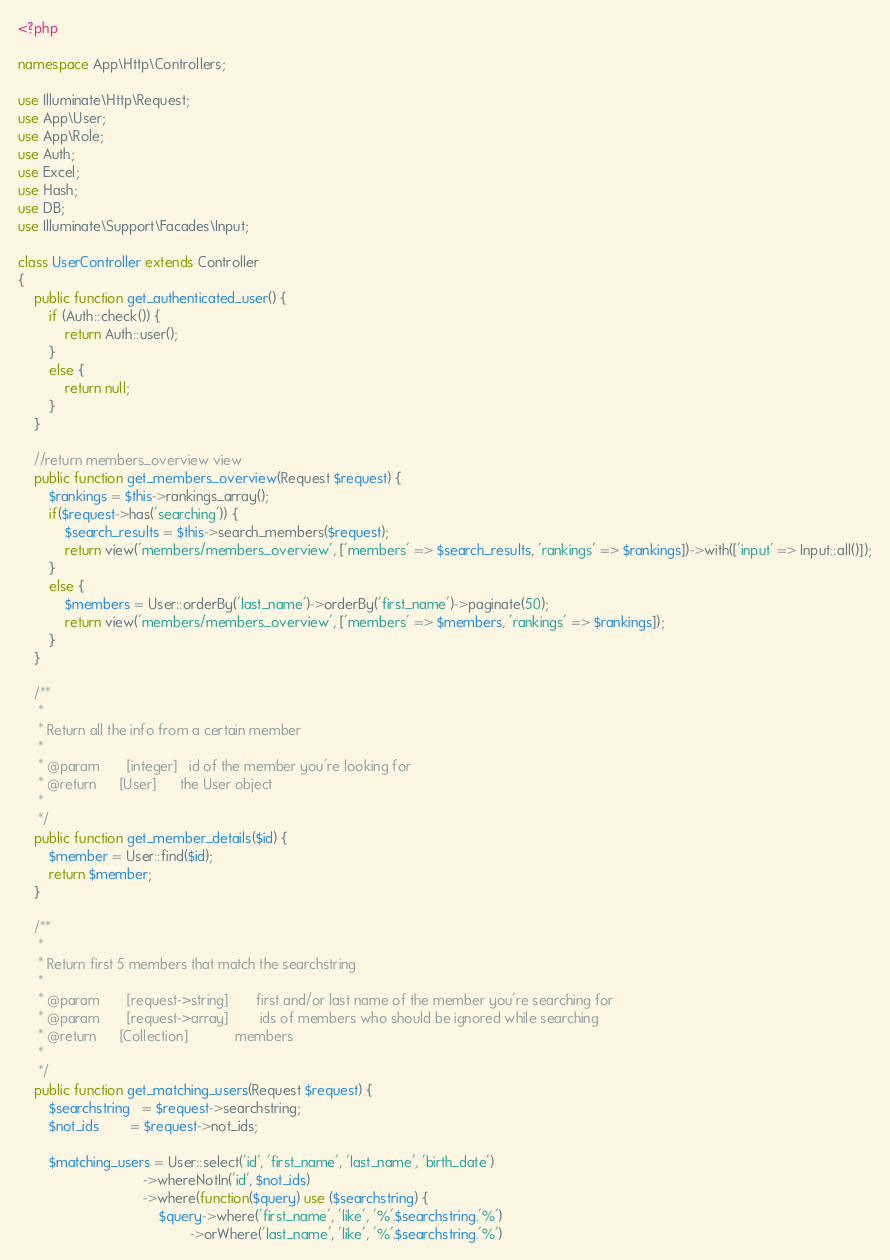Convert code to text. <code><loc_0><loc_0><loc_500><loc_500><_PHP_><?php

namespace App\Http\Controllers;

use Illuminate\Http\Request;
use App\User;
use App\Role;
use Auth;
use Excel;
use Hash;
use DB;
use Illuminate\Support\Facades\Input;

class UserController extends Controller
{
    public function get_authenticated_user() {
        if (Auth::check()) {
            return Auth::user();
        }
        else {
            return null;
        }
    }

    //return members_overview view
    public function get_members_overview(Request $request) {
        $rankings = $this->rankings_array();
        if($request->has('searching')) {
            $search_results = $this->search_members($request);
            return view('members/members_overview', ['members' => $search_results, 'rankings' => $rankings])->with(['input' => Input::all()]);
        }
        else {
            $members = User::orderBy('last_name')->orderBy('first_name')->paginate(50);
            return view('members/members_overview', ['members' => $members, 'rankings' => $rankings]);
        }
    }

    /**
     *
     * Return all the info from a certain member
     *
     * @param       [integer]   id of the member you're looking for
     * @return      [User]      the User object
     *
     */
    public function get_member_details($id) {
        $member = User::find($id);
        return $member;
    }

    /**
     *
     * Return first 5 members that match the searchstring
     *
     * @param       [request->string]       first and/or last name of the member you're searching for
     * @param       [request->array]        ids of members who should be ignored while searching
     * @return      [Collection]            members
     *
     */
    public function get_matching_users(Request $request) {
        $searchstring   = $request->searchstring;
        $not_ids        = $request->not_ids;

        $matching_users = User::select('id', 'first_name', 'last_name', 'birth_date')
                                ->whereNotIn('id', $not_ids)
                                ->where(function($query) use ($searchstring) {
                                    $query->where('first_name', 'like', '%'.$searchstring.'%')
                                            ->orWhere('last_name', 'like', '%'.$searchstring.'%')</code> 